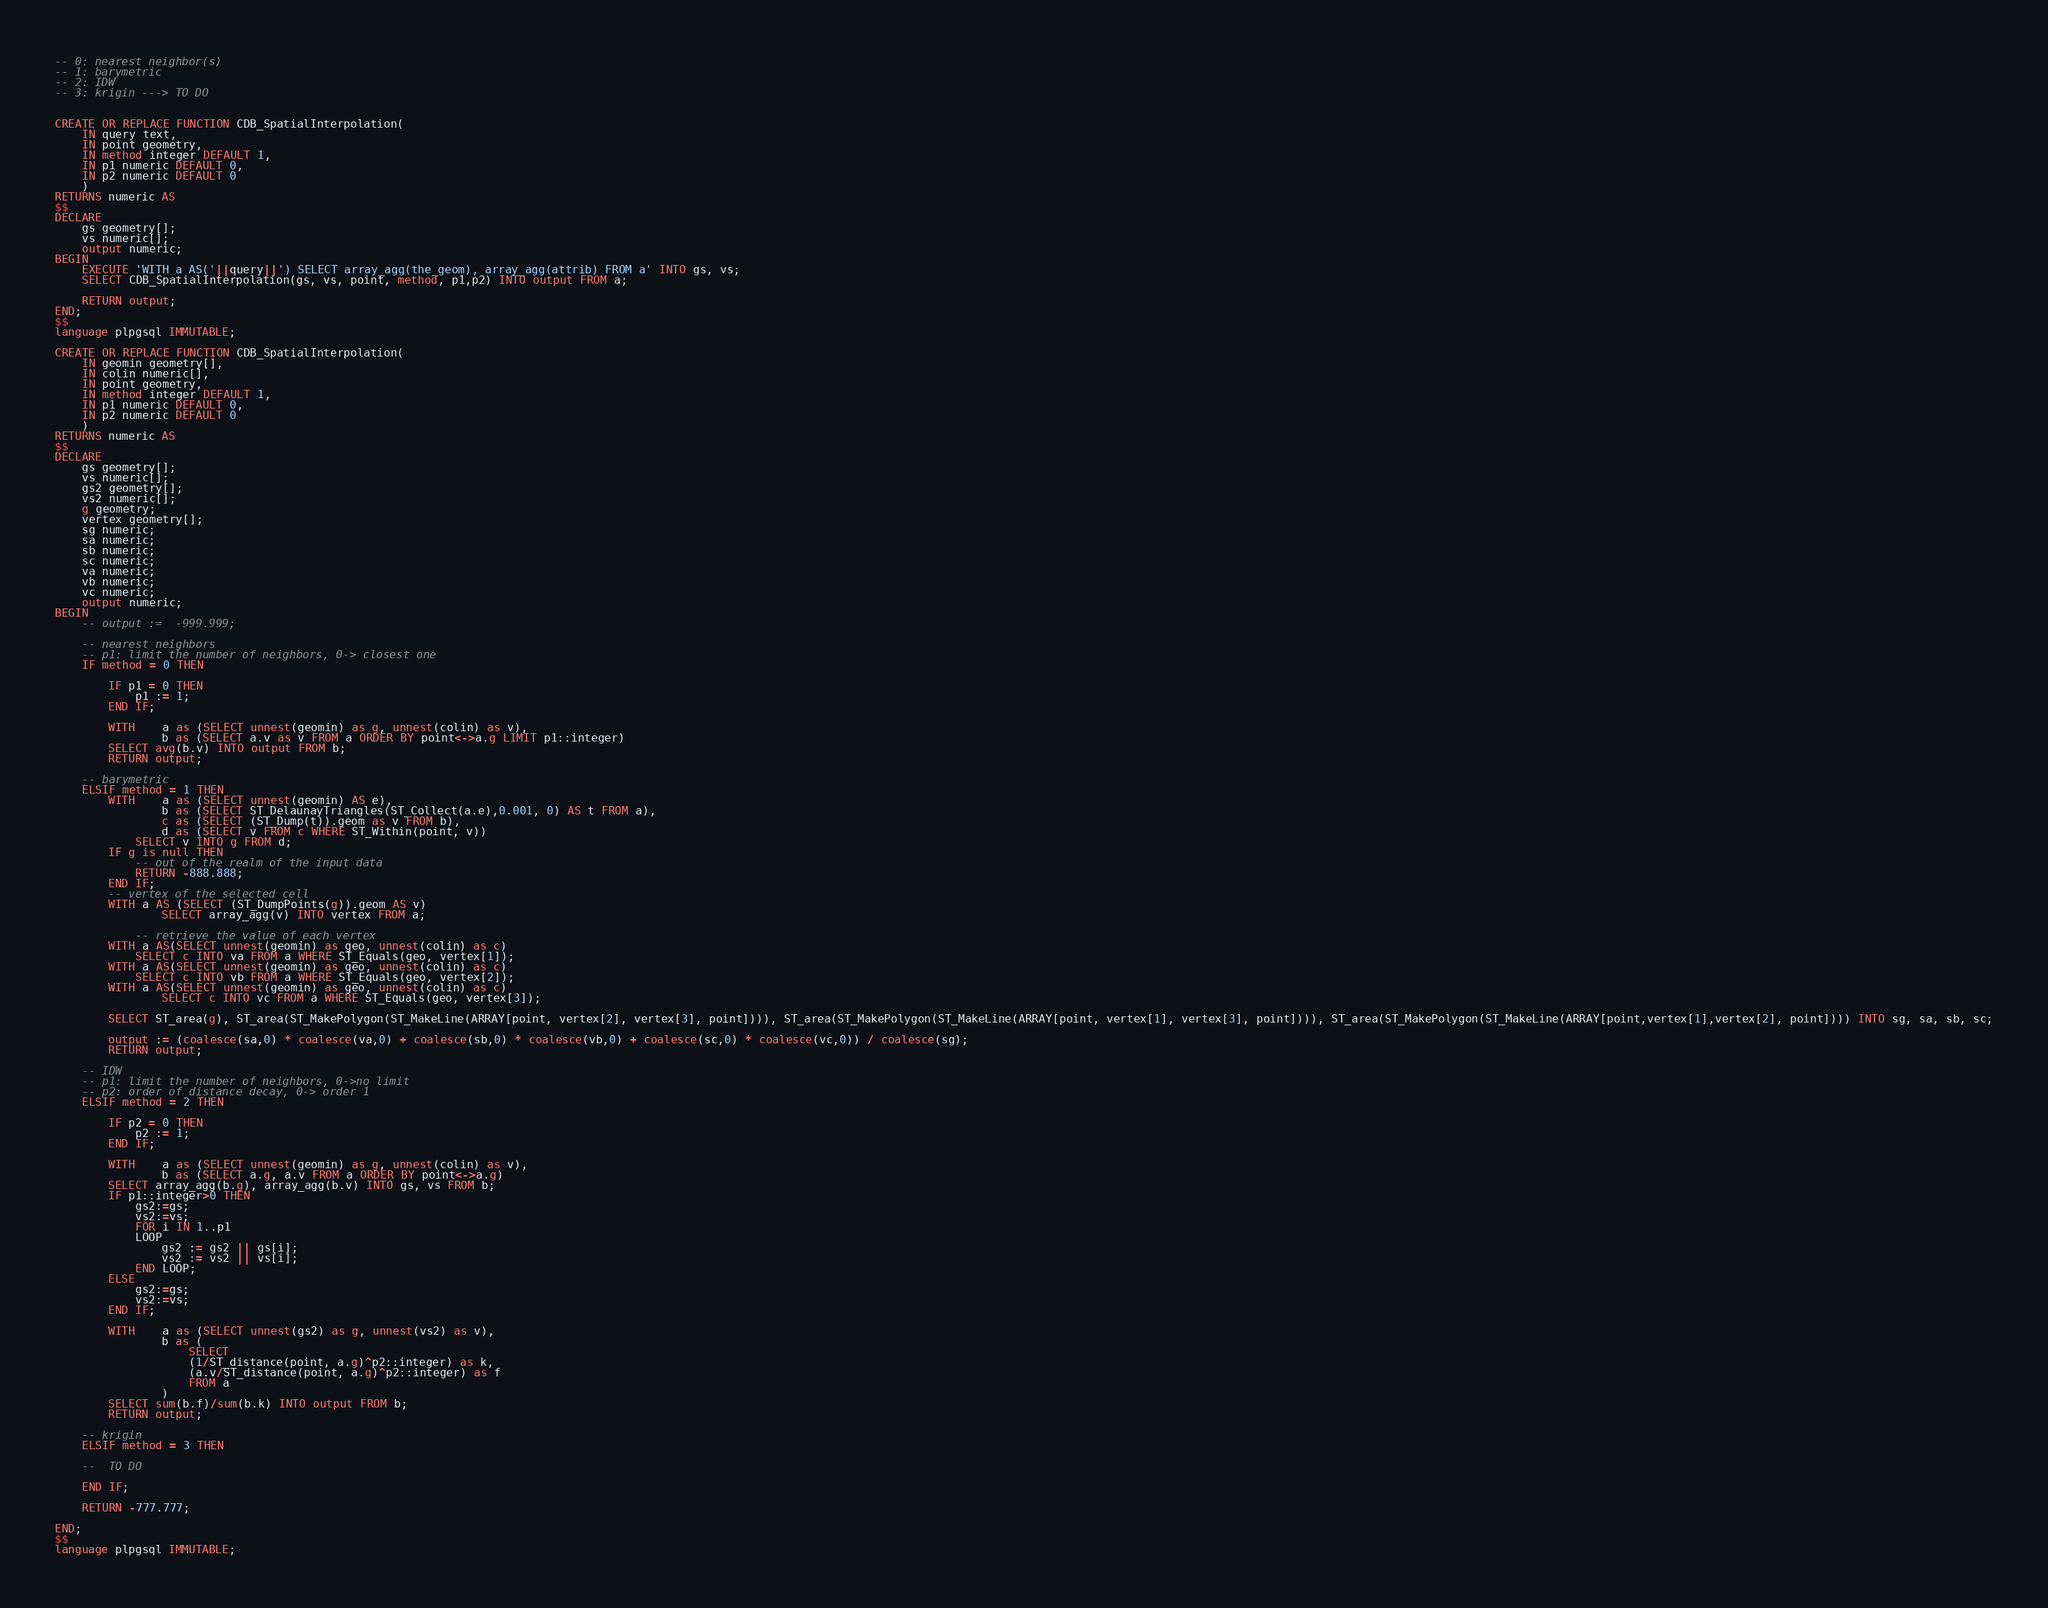<code> <loc_0><loc_0><loc_500><loc_500><_SQL_>-- 0: nearest neighbor(s)
-- 1: barymetric
-- 2: IDW
-- 3: krigin ---> TO DO


CREATE OR REPLACE FUNCTION CDB_SpatialInterpolation(
    IN query text,
    IN point geometry,
    IN method integer DEFAULT 1,
    IN p1 numeric DEFAULT 0,
    IN p2 numeric DEFAULT 0
    )
RETURNS numeric AS
$$
DECLARE
    gs geometry[];
    vs numeric[];
    output numeric;
BEGIN
    EXECUTE 'WITH a AS('||query||') SELECT array_agg(the_geom), array_agg(attrib) FROM a' INTO gs, vs;
    SELECT CDB_SpatialInterpolation(gs, vs, point, method, p1,p2) INTO output FROM a;

    RETURN output;
END;
$$
language plpgsql IMMUTABLE;

CREATE OR REPLACE FUNCTION CDB_SpatialInterpolation(
    IN geomin geometry[],
    IN colin numeric[],
    IN point geometry,
    IN method integer DEFAULT 1,
    IN p1 numeric DEFAULT 0,
    IN p2 numeric DEFAULT 0
    )
RETURNS numeric AS
$$
DECLARE
    gs geometry[];
    vs numeric[];
    gs2 geometry[];
    vs2 numeric[];
    g geometry;
    vertex geometry[];
    sg numeric;
    sa numeric;
    sb numeric;
    sc numeric;
    va numeric;
    vb numeric;
    vc numeric;
    output numeric;
BEGIN
    -- output :=  -999.999;

    -- nearest neighbors
    -- p1: limit the number of neighbors, 0-> closest one
    IF method = 0 THEN

        IF p1 = 0 THEN
            p1 := 1;
        END IF;

        WITH    a as (SELECT unnest(geomin) as g, unnest(colin) as v),
                b as (SELECT a.v as v FROM a ORDER BY point<->a.g LIMIT p1::integer)
        SELECT avg(b.v) INTO output FROM b;
        RETURN output;

    -- barymetric
    ELSIF method = 1 THEN
        WITH    a as (SELECT unnest(geomin) AS e),
                b as (SELECT ST_DelaunayTriangles(ST_Collect(a.e),0.001, 0) AS t FROM a),
                c as (SELECT (ST_Dump(t)).geom as v FROM b),
                d as (SELECT v FROM c WHERE ST_Within(point, v))
            SELECT v INTO g FROM d;
        IF g is null THEN
            -- out of the realm of the input data
            RETURN -888.888;
        END IF;
        -- vertex of the selected cell
        WITH a AS (SELECT (ST_DumpPoints(g)).geom AS v)
                SELECT array_agg(v) INTO vertex FROM a;

            -- retrieve the value of each vertex
        WITH a AS(SELECT unnest(geomin) as geo, unnest(colin) as c)
            SELECT c INTO va FROM a WHERE ST_Equals(geo, vertex[1]);
        WITH a AS(SELECT unnest(geomin) as geo, unnest(colin) as c)
            SELECT c INTO vb FROM a WHERE ST_Equals(geo, vertex[2]);
        WITH a AS(SELECT unnest(geomin) as geo, unnest(colin) as c)
                SELECT c INTO vc FROM a WHERE ST_Equals(geo, vertex[3]);

        SELECT ST_area(g), ST_area(ST_MakePolygon(ST_MakeLine(ARRAY[point, vertex[2], vertex[3], point]))), ST_area(ST_MakePolygon(ST_MakeLine(ARRAY[point, vertex[1], vertex[3], point]))), ST_area(ST_MakePolygon(ST_MakeLine(ARRAY[point,vertex[1],vertex[2], point]))) INTO sg, sa, sb, sc;

        output := (coalesce(sa,0) * coalesce(va,0) + coalesce(sb,0) * coalesce(vb,0) + coalesce(sc,0) * coalesce(vc,0)) / coalesce(sg);
        RETURN output;

    -- IDW
    -- p1: limit the number of neighbors, 0->no limit
    -- p2: order of distance decay, 0-> order 1
    ELSIF method = 2 THEN

        IF p2 = 0 THEN
            p2 := 1;
        END IF;

        WITH    a as (SELECT unnest(geomin) as g, unnest(colin) as v),
                b as (SELECT a.g, a.v FROM a ORDER BY point<->a.g)
        SELECT array_agg(b.g), array_agg(b.v) INTO gs, vs FROM b;
        IF p1::integer>0 THEN
            gs2:=gs;
            vs2:=vs;
            FOR i IN 1..p1
            LOOP
                gs2 := gs2 || gs[i];
                vs2 := vs2 || vs[i];
            END LOOP;
        ELSE
            gs2:=gs;
            vs2:=vs;
        END IF;

        WITH    a as (SELECT unnest(gs2) as g, unnest(vs2) as v),
                b as (
                    SELECT
                    (1/ST_distance(point, a.g)^p2::integer) as k,
                    (a.v/ST_distance(point, a.g)^p2::integer) as f
                    FROM a
                )
        SELECT sum(b.f)/sum(b.k) INTO output FROM b;
        RETURN output;

    -- krigin
    ELSIF method = 3 THEN

    --  TO DO

    END IF;

    RETURN -777.777;

END;
$$
language plpgsql IMMUTABLE;
</code> 